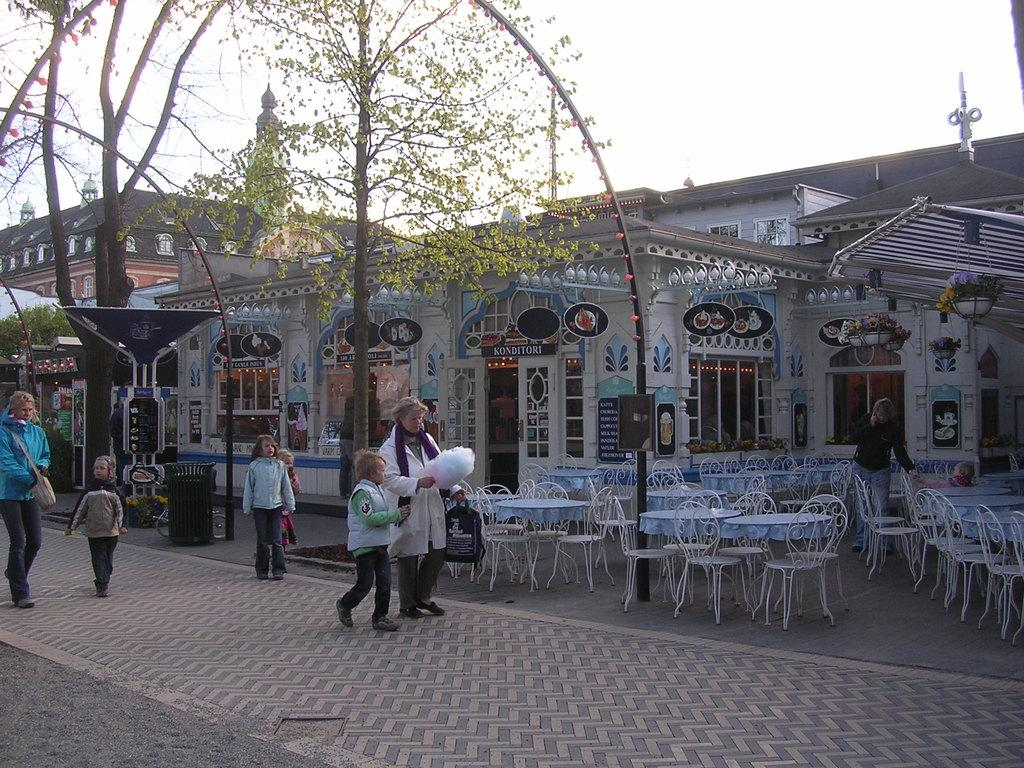What are the persons in the image doing? The persons in the image are walking on the road. What are the persons carrying while walking? The persons are holding backpacks. What can be seen in the background of the image? In the background, there is a sky, clouds, trees, at least one building, a wall, tables, chairs, and a light source. What type of wool is being used to create the hole in the image? There is no wool or hole present in the image. What type of slave is depicted in the image? There is no depiction of a slave in the image. 